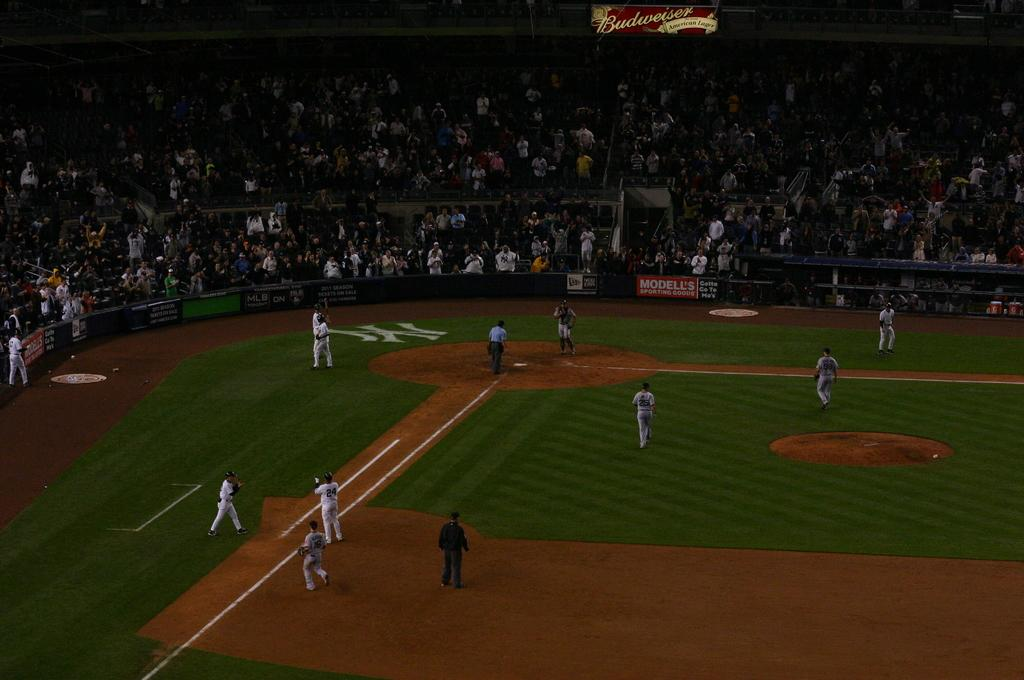<image>
Share a concise interpretation of the image provided. Baseball players are playing a game in front of a crowd and a sign for Budweiser is above them. 